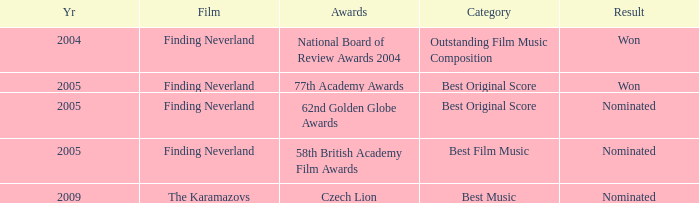How many years were there for the 62nd golden globe awards? 2005.0. 